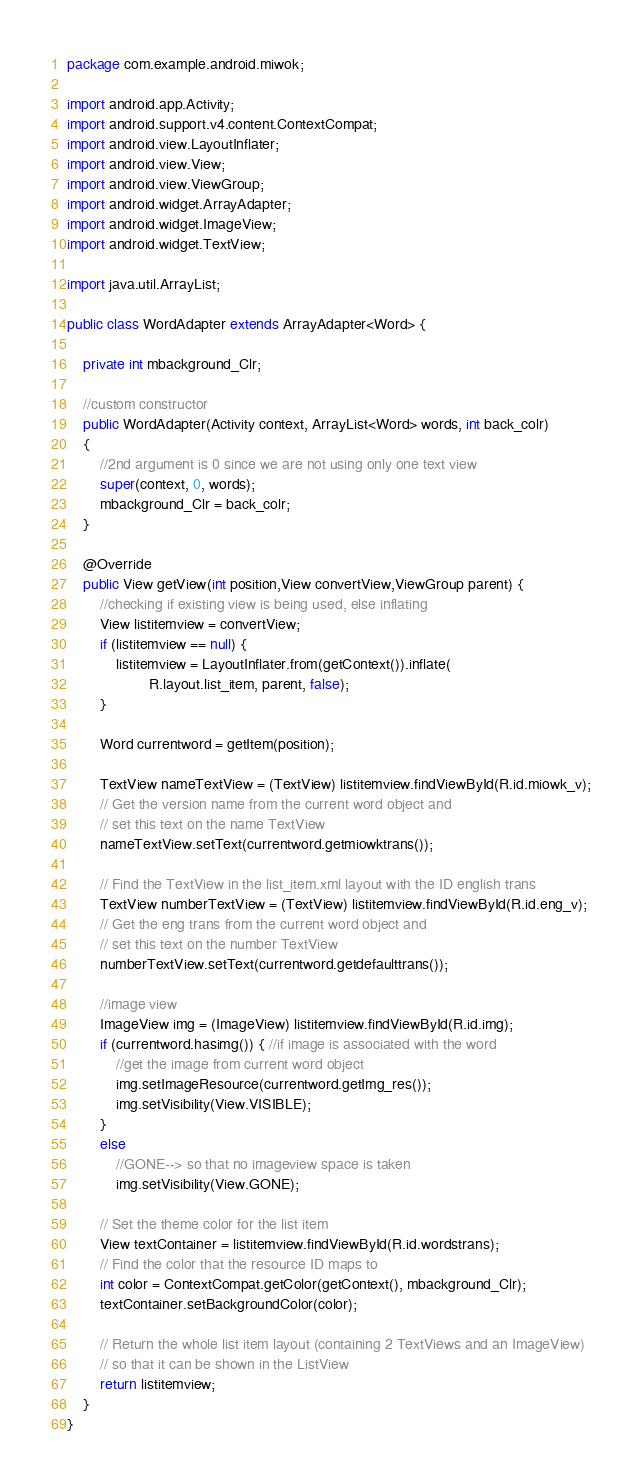Convert code to text. <code><loc_0><loc_0><loc_500><loc_500><_Java_>package com.example.android.miwok;

import android.app.Activity;
import android.support.v4.content.ContextCompat;
import android.view.LayoutInflater;
import android.view.View;
import android.view.ViewGroup;
import android.widget.ArrayAdapter;
import android.widget.ImageView;
import android.widget.TextView;

import java.util.ArrayList;

public class WordAdapter extends ArrayAdapter<Word> {

    private int mbackground_Clr;

    //custom constructor
    public WordAdapter(Activity context, ArrayList<Word> words, int back_colr)
    {
        //2nd argument is 0 since we are not using only one text view
        super(context, 0, words);
        mbackground_Clr = back_colr;
    }

    @Override
    public View getView(int position,View convertView,ViewGroup parent) {
        //checking if existing view is being used, else inflating
        View listitemview = convertView;
        if (listitemview == null) {
            listitemview = LayoutInflater.from(getContext()).inflate(
                    R.layout.list_item, parent, false);
        }

        Word currentword = getItem(position);

        TextView nameTextView = (TextView) listitemview.findViewById(R.id.miowk_v);
        // Get the version name from the current word object and
        // set this text on the name TextView
        nameTextView.setText(currentword.getmiowktrans());

        // Find the TextView in the list_item.xml layout with the ID english trans
        TextView numberTextView = (TextView) listitemview.findViewById(R.id.eng_v);
        // Get the eng trans from the current word object and
        // set this text on the number TextView
        numberTextView.setText(currentword.getdefaulttrans());

        //image view
        ImageView img = (ImageView) listitemview.findViewById(R.id.img);
        if (currentword.hasimg()) { //if image is associated with the word
            //get the image from current word object
            img.setImageResource(currentword.getImg_res());
            img.setVisibility(View.VISIBLE);
        }
        else
            //GONE--> so that no imageview space is taken
            img.setVisibility(View.GONE);

        // Set the theme color for the list item
        View textContainer = listitemview.findViewById(R.id.wordstrans);
        // Find the color that the resource ID maps to
        int color = ContextCompat.getColor(getContext(), mbackground_Clr);
        textContainer.setBackgroundColor(color);

        // Return the whole list item layout (containing 2 TextViews and an ImageView)
        // so that it can be shown in the ListView
        return listitemview;
    }
}
</code> 